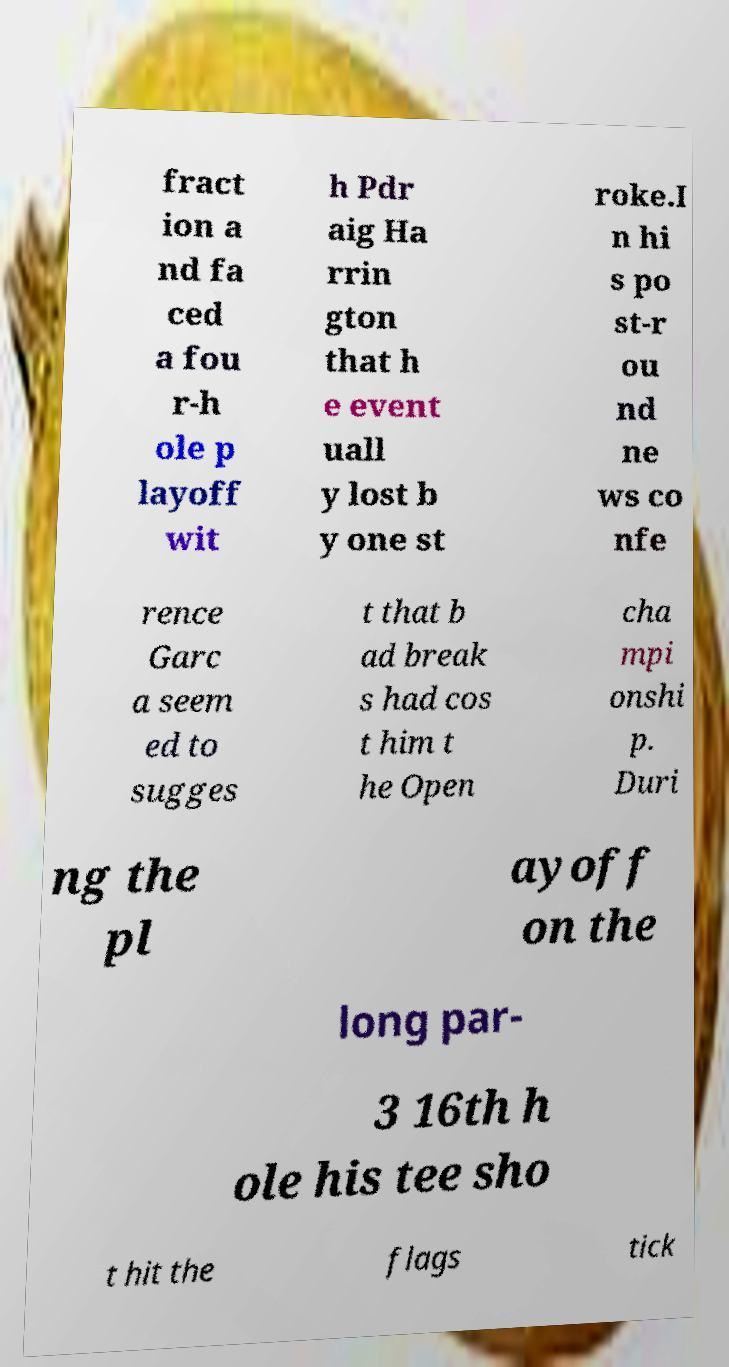Can you accurately transcribe the text from the provided image for me? fract ion a nd fa ced a fou r-h ole p layoff wit h Pdr aig Ha rrin gton that h e event uall y lost b y one st roke.I n hi s po st-r ou nd ne ws co nfe rence Garc a seem ed to sugges t that b ad break s had cos t him t he Open cha mpi onshi p. Duri ng the pl ayoff on the long par- 3 16th h ole his tee sho t hit the flags tick 